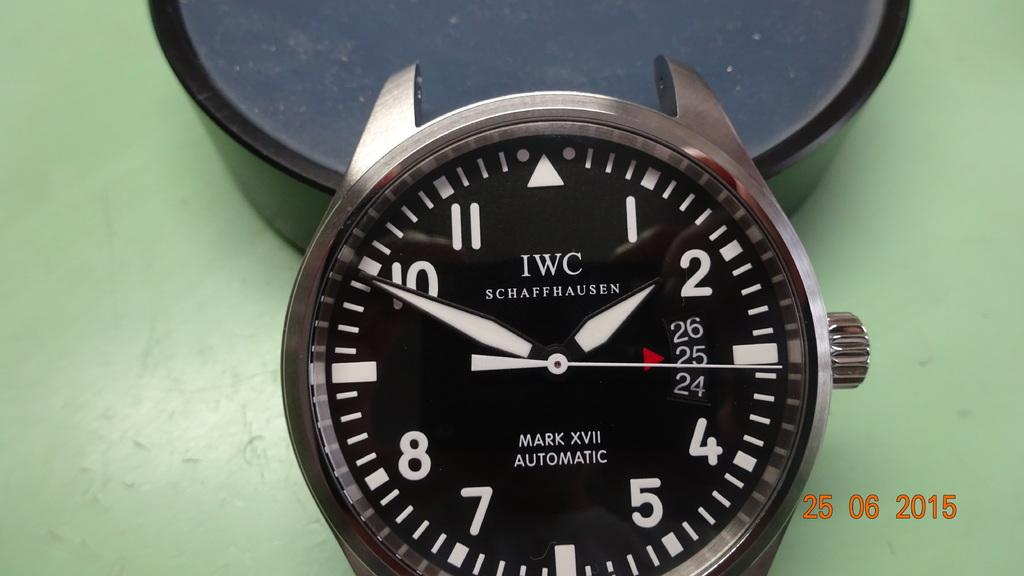<image>
Share a concise interpretation of the image provided. An IWC watch says that it is a Mark XVII automatic. 